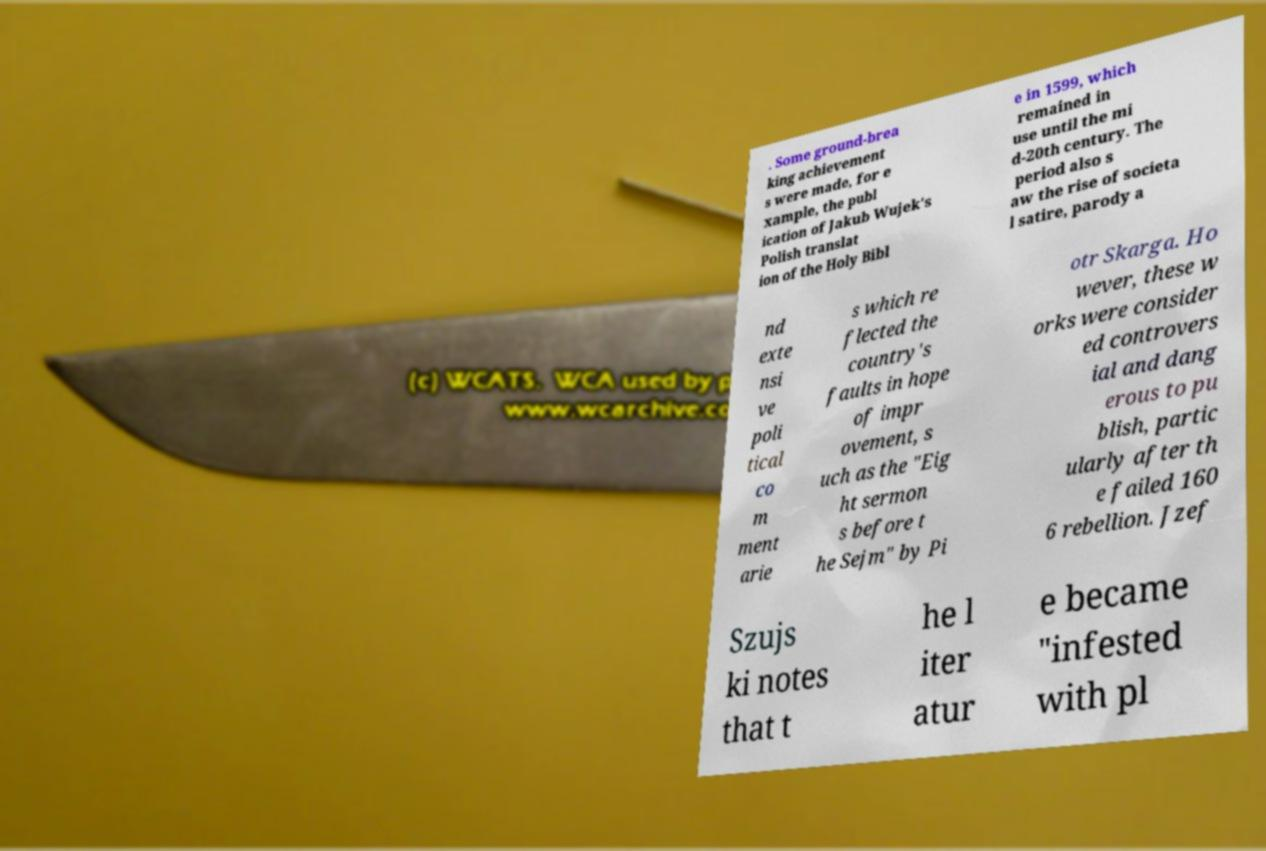Please read and relay the text visible in this image. What does it say? . Some ground-brea king achievement s were made, for e xample, the publ ication of Jakub Wujek's Polish translat ion of the Holy Bibl e in 1599, which remained in use until the mi d-20th century. The period also s aw the rise of societa l satire, parody a nd exte nsi ve poli tical co m ment arie s which re flected the country's faults in hope of impr ovement, s uch as the "Eig ht sermon s before t he Sejm" by Pi otr Skarga. Ho wever, these w orks were consider ed controvers ial and dang erous to pu blish, partic ularly after th e failed 160 6 rebellion. Jzef Szujs ki notes that t he l iter atur e became "infested with pl 